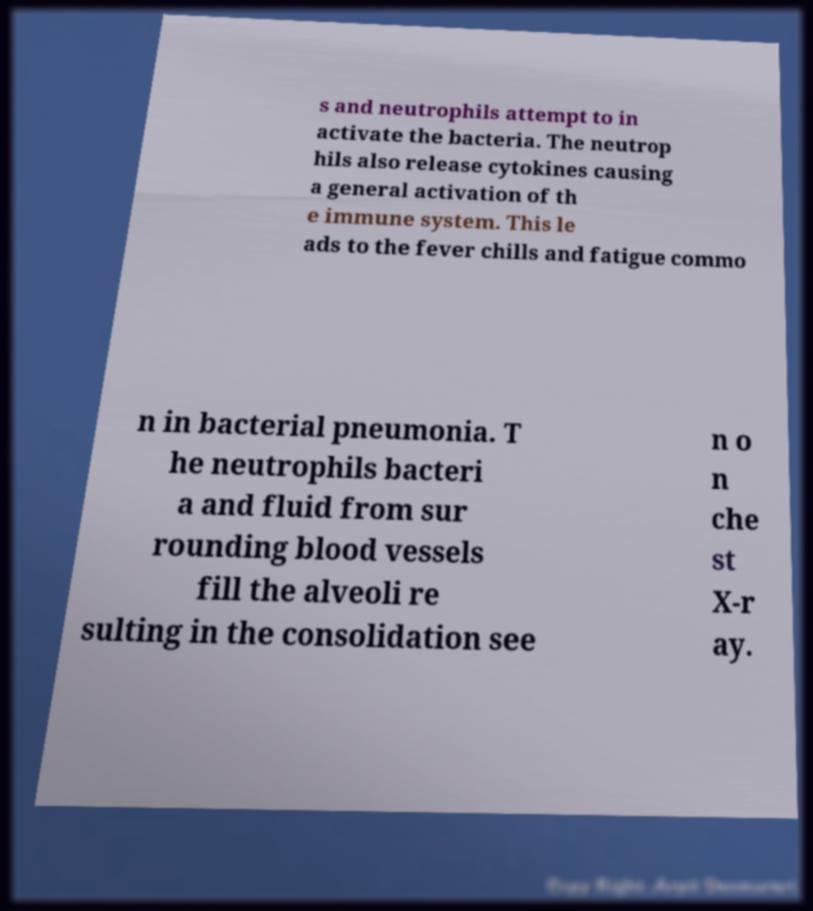I need the written content from this picture converted into text. Can you do that? s and neutrophils attempt to in activate the bacteria. The neutrop hils also release cytokines causing a general activation of th e immune system. This le ads to the fever chills and fatigue commo n in bacterial pneumonia. T he neutrophils bacteri a and fluid from sur rounding blood vessels fill the alveoli re sulting in the consolidation see n o n che st X-r ay. 